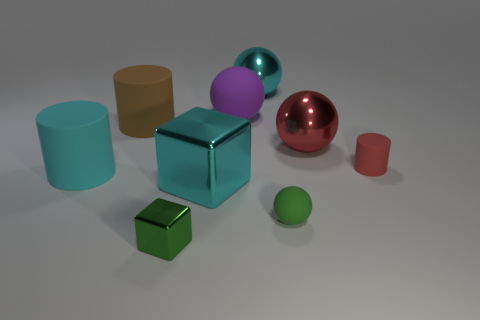Subtract all cyan spheres. How many spheres are left? 3 Subtract all gray balls. Subtract all blue cylinders. How many balls are left? 4 Add 1 brown rubber cylinders. How many objects exist? 10 Subtract all balls. How many objects are left? 5 Add 6 large rubber spheres. How many large rubber spheres are left? 7 Add 3 big metal cylinders. How many big metal cylinders exist? 3 Subtract 0 purple blocks. How many objects are left? 9 Subtract all small gray shiny cylinders. Subtract all brown matte objects. How many objects are left? 8 